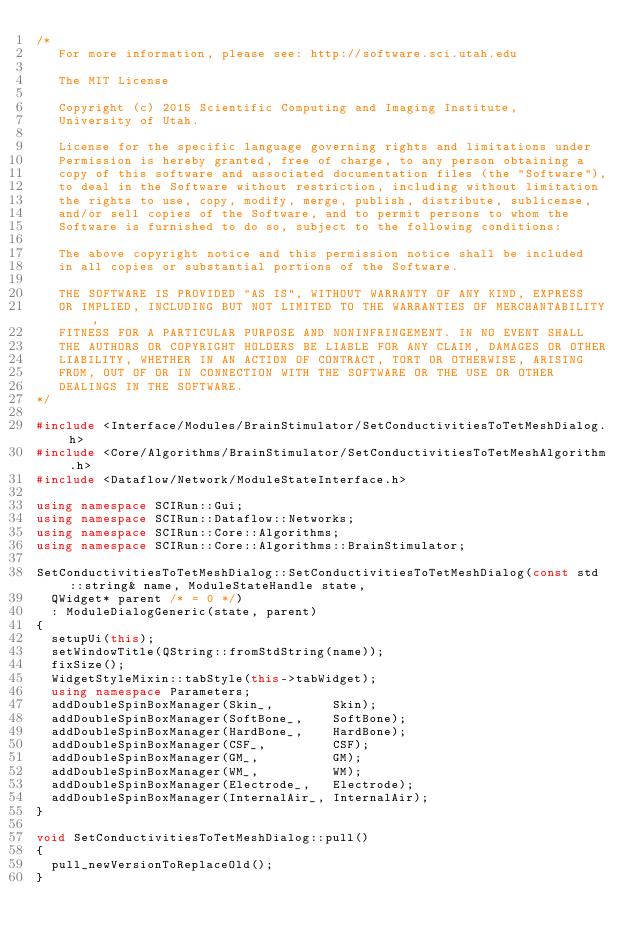<code> <loc_0><loc_0><loc_500><loc_500><_C++_>/*
   For more information, please see: http://software.sci.utah.edu

   The MIT License

   Copyright (c) 2015 Scientific Computing and Imaging Institute,
   University of Utah.

   License for the specific language governing rights and limitations under
   Permission is hereby granted, free of charge, to any person obtaining a
   copy of this software and associated documentation files (the "Software"),
   to deal in the Software without restriction, including without limitation
   the rights to use, copy, modify, merge, publish, distribute, sublicense,
   and/or sell copies of the Software, and to permit persons to whom the
   Software is furnished to do so, subject to the following conditions:

   The above copyright notice and this permission notice shall be included
   in all copies or substantial portions of the Software.

   THE SOFTWARE IS PROVIDED "AS IS", WITHOUT WARRANTY OF ANY KIND, EXPRESS
   OR IMPLIED, INCLUDING BUT NOT LIMITED TO THE WARRANTIES OF MERCHANTABILITY,
   FITNESS FOR A PARTICULAR PURPOSE AND NONINFRINGEMENT. IN NO EVENT SHALL
   THE AUTHORS OR COPYRIGHT HOLDERS BE LIABLE FOR ANY CLAIM, DAMAGES OR OTHER
   LIABILITY, WHETHER IN AN ACTION OF CONTRACT, TORT OR OTHERWISE, ARISING
   FROM, OUT OF OR IN CONNECTION WITH THE SOFTWARE OR THE USE OR OTHER
   DEALINGS IN THE SOFTWARE.
*/

#include <Interface/Modules/BrainStimulator/SetConductivitiesToTetMeshDialog.h>
#include <Core/Algorithms/BrainStimulator/SetConductivitiesToTetMeshAlgorithm.h>
#include <Dataflow/Network/ModuleStateInterface.h>

using namespace SCIRun::Gui;
using namespace SCIRun::Dataflow::Networks;
using namespace SCIRun::Core::Algorithms;
using namespace SCIRun::Core::Algorithms::BrainStimulator;

SetConductivitiesToTetMeshDialog::SetConductivitiesToTetMeshDialog(const std::string& name, ModuleStateHandle state,
  QWidget* parent /* = 0 */)
  : ModuleDialogGeneric(state, parent)
{
  setupUi(this);
  setWindowTitle(QString::fromStdString(name));
  fixSize();
  WidgetStyleMixin::tabStyle(this->tabWidget); 
  using namespace Parameters;
  addDoubleSpinBoxManager(Skin_,        Skin);
  addDoubleSpinBoxManager(SoftBone_,    SoftBone);
  addDoubleSpinBoxManager(HardBone_,    HardBone);
  addDoubleSpinBoxManager(CSF_,         CSF);
  addDoubleSpinBoxManager(GM_,          GM);
  addDoubleSpinBoxManager(WM_,          WM);
  addDoubleSpinBoxManager(Electrode_,   Electrode);
  addDoubleSpinBoxManager(InternalAir_, InternalAir);
}

void SetConductivitiesToTetMeshDialog::pull()
{
  pull_newVersionToReplaceOld();
}
</code> 